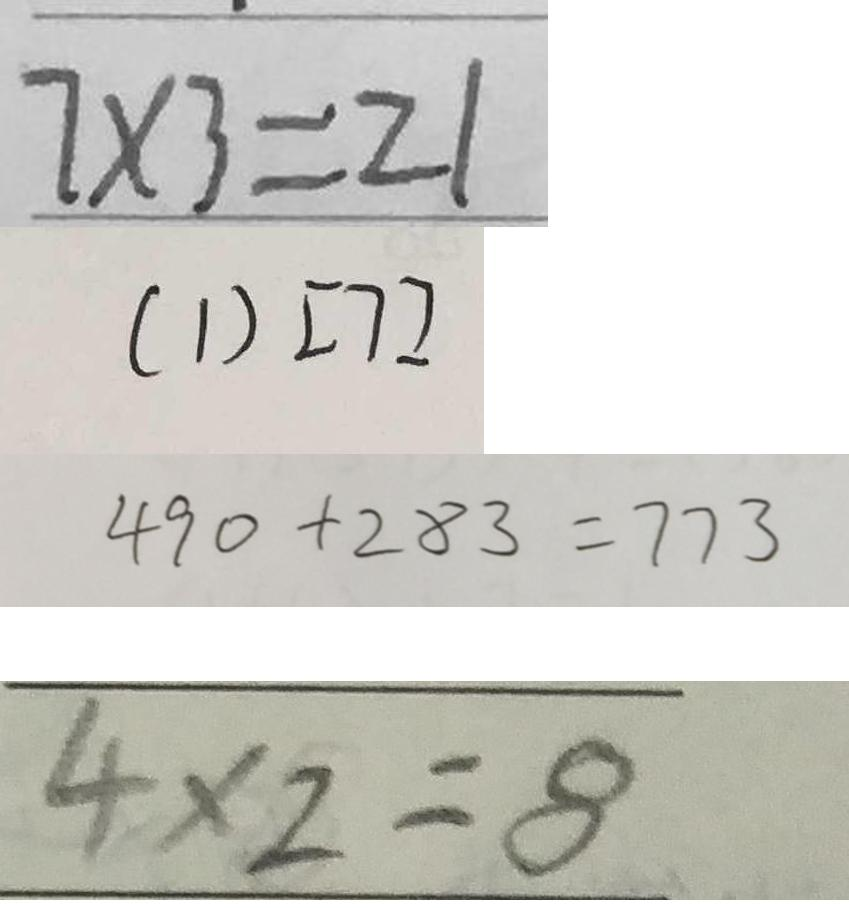<formula> <loc_0><loc_0><loc_500><loc_500>7 \times 3 = 2 1 
 ( 1 ) [ 7 ] 
 4 9 0 + 2 8 3 = 7 7 3 
 4 \times 2 = 8</formula> 